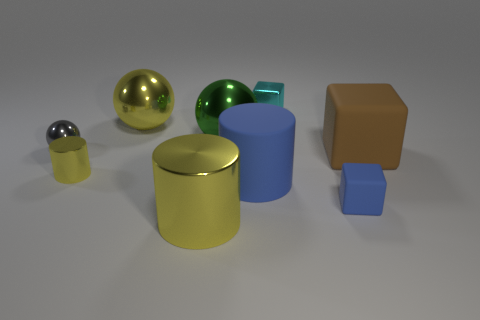Is the number of shiny cylinders greater than the number of cyan blocks?
Offer a very short reply. Yes. Does the big block have the same material as the small blue block?
Ensure brevity in your answer.  Yes. Is the number of brown rubber things that are to the left of the big yellow shiny ball the same as the number of small blue matte cylinders?
Your answer should be very brief. Yes. How many cyan blocks are made of the same material as the tiny yellow cylinder?
Your response must be concise. 1. Is the number of blue cylinders less than the number of big gray matte objects?
Your answer should be compact. No. Is the color of the metallic object in front of the big blue cylinder the same as the small metal sphere?
Provide a short and direct response. No. There is a yellow cylinder behind the large yellow thing that is in front of the yellow sphere; how many big brown rubber things are in front of it?
Your answer should be very brief. 0. How many gray things are in front of the large green ball?
Your response must be concise. 1. There is another big thing that is the same shape as the big blue object; what is its color?
Ensure brevity in your answer.  Yellow. What is the material of the big thing that is in front of the yellow metal ball and behind the tiny gray metal object?
Provide a succinct answer. Metal. 